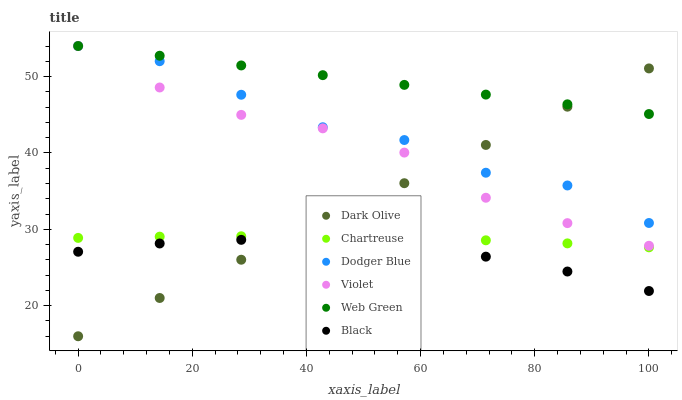Does Black have the minimum area under the curve?
Answer yes or no. Yes. Does Web Green have the maximum area under the curve?
Answer yes or no. Yes. Does Chartreuse have the minimum area under the curve?
Answer yes or no. No. Does Chartreuse have the maximum area under the curve?
Answer yes or no. No. Is Web Green the smoothest?
Answer yes or no. Yes. Is Dodger Blue the roughest?
Answer yes or no. Yes. Is Chartreuse the smoothest?
Answer yes or no. No. Is Chartreuse the roughest?
Answer yes or no. No. Does Dark Olive have the lowest value?
Answer yes or no. Yes. Does Chartreuse have the lowest value?
Answer yes or no. No. Does Dodger Blue have the highest value?
Answer yes or no. Yes. Does Chartreuse have the highest value?
Answer yes or no. No. Is Chartreuse less than Dodger Blue?
Answer yes or no. Yes. Is Violet greater than Chartreuse?
Answer yes or no. Yes. Does Dodger Blue intersect Web Green?
Answer yes or no. Yes. Is Dodger Blue less than Web Green?
Answer yes or no. No. Is Dodger Blue greater than Web Green?
Answer yes or no. No. Does Chartreuse intersect Dodger Blue?
Answer yes or no. No. 